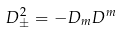Convert formula to latex. <formula><loc_0><loc_0><loc_500><loc_500>D _ { \pm } ^ { 2 } = - D _ { m } D ^ { m }</formula> 